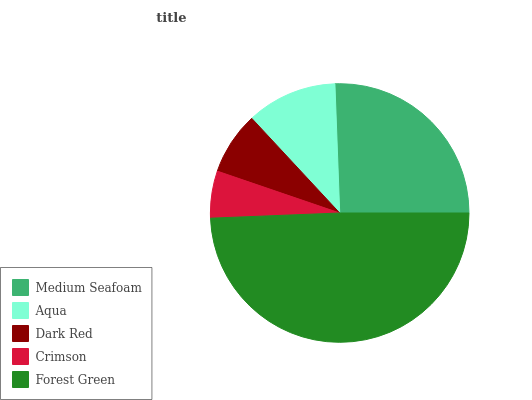Is Crimson the minimum?
Answer yes or no. Yes. Is Forest Green the maximum?
Answer yes or no. Yes. Is Aqua the minimum?
Answer yes or no. No. Is Aqua the maximum?
Answer yes or no. No. Is Medium Seafoam greater than Aqua?
Answer yes or no. Yes. Is Aqua less than Medium Seafoam?
Answer yes or no. Yes. Is Aqua greater than Medium Seafoam?
Answer yes or no. No. Is Medium Seafoam less than Aqua?
Answer yes or no. No. Is Aqua the high median?
Answer yes or no. Yes. Is Aqua the low median?
Answer yes or no. Yes. Is Forest Green the high median?
Answer yes or no. No. Is Dark Red the low median?
Answer yes or no. No. 